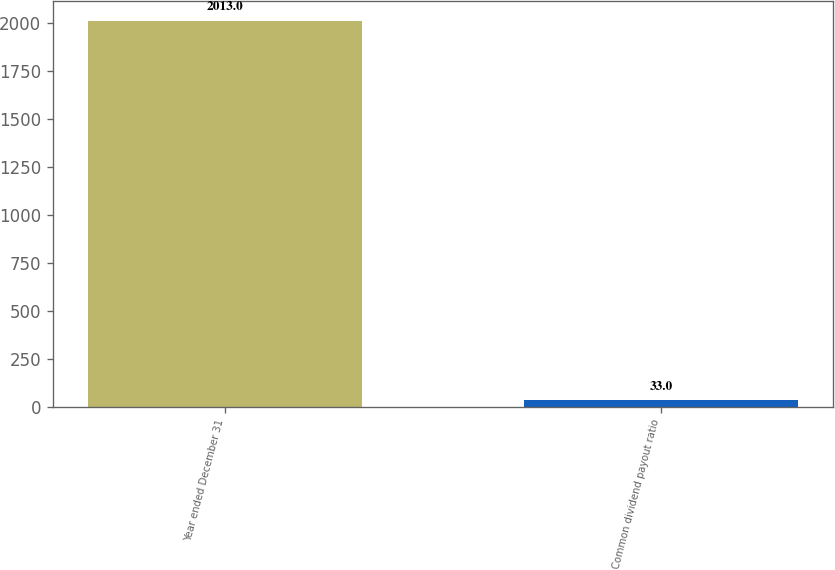Convert chart. <chart><loc_0><loc_0><loc_500><loc_500><bar_chart><fcel>Year ended December 31<fcel>Common dividend payout ratio<nl><fcel>2013<fcel>33<nl></chart> 